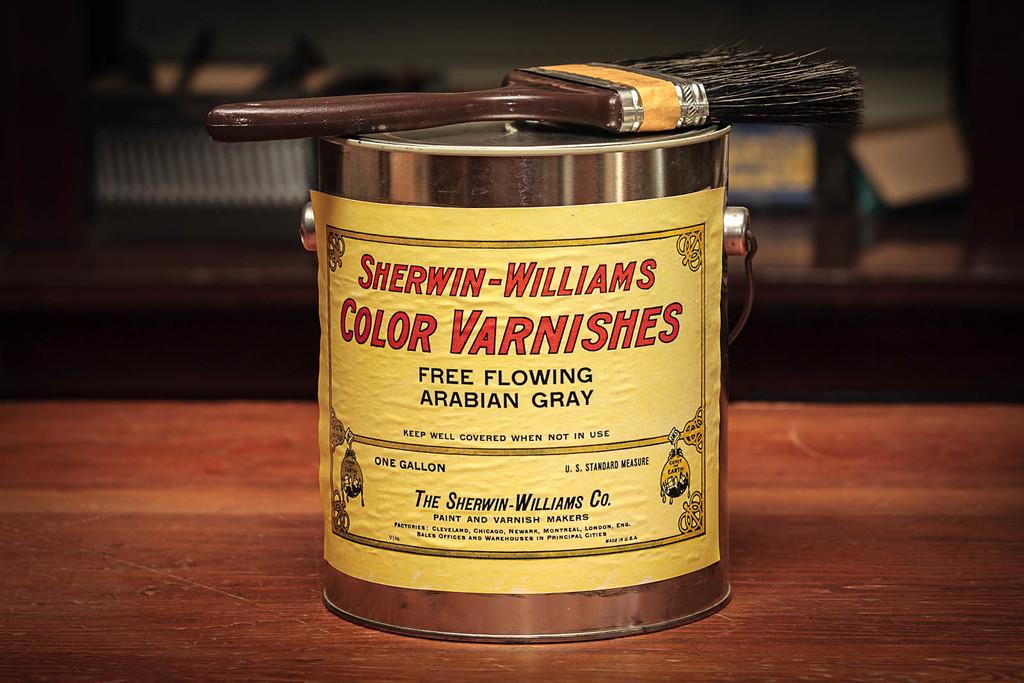What is the brand name?
Give a very brief answer. Sherwin williams. 